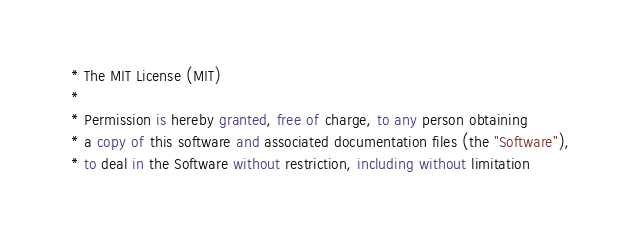Convert code to text. <code><loc_0><loc_0><loc_500><loc_500><_SQL_> * The MIT License (MIT)
 * 
 * Permission is hereby granted, free of charge, to any person obtaining
 * a copy of this software and associated documentation files (the "Software"),
 * to deal in the Software without restriction, including without limitation</code> 